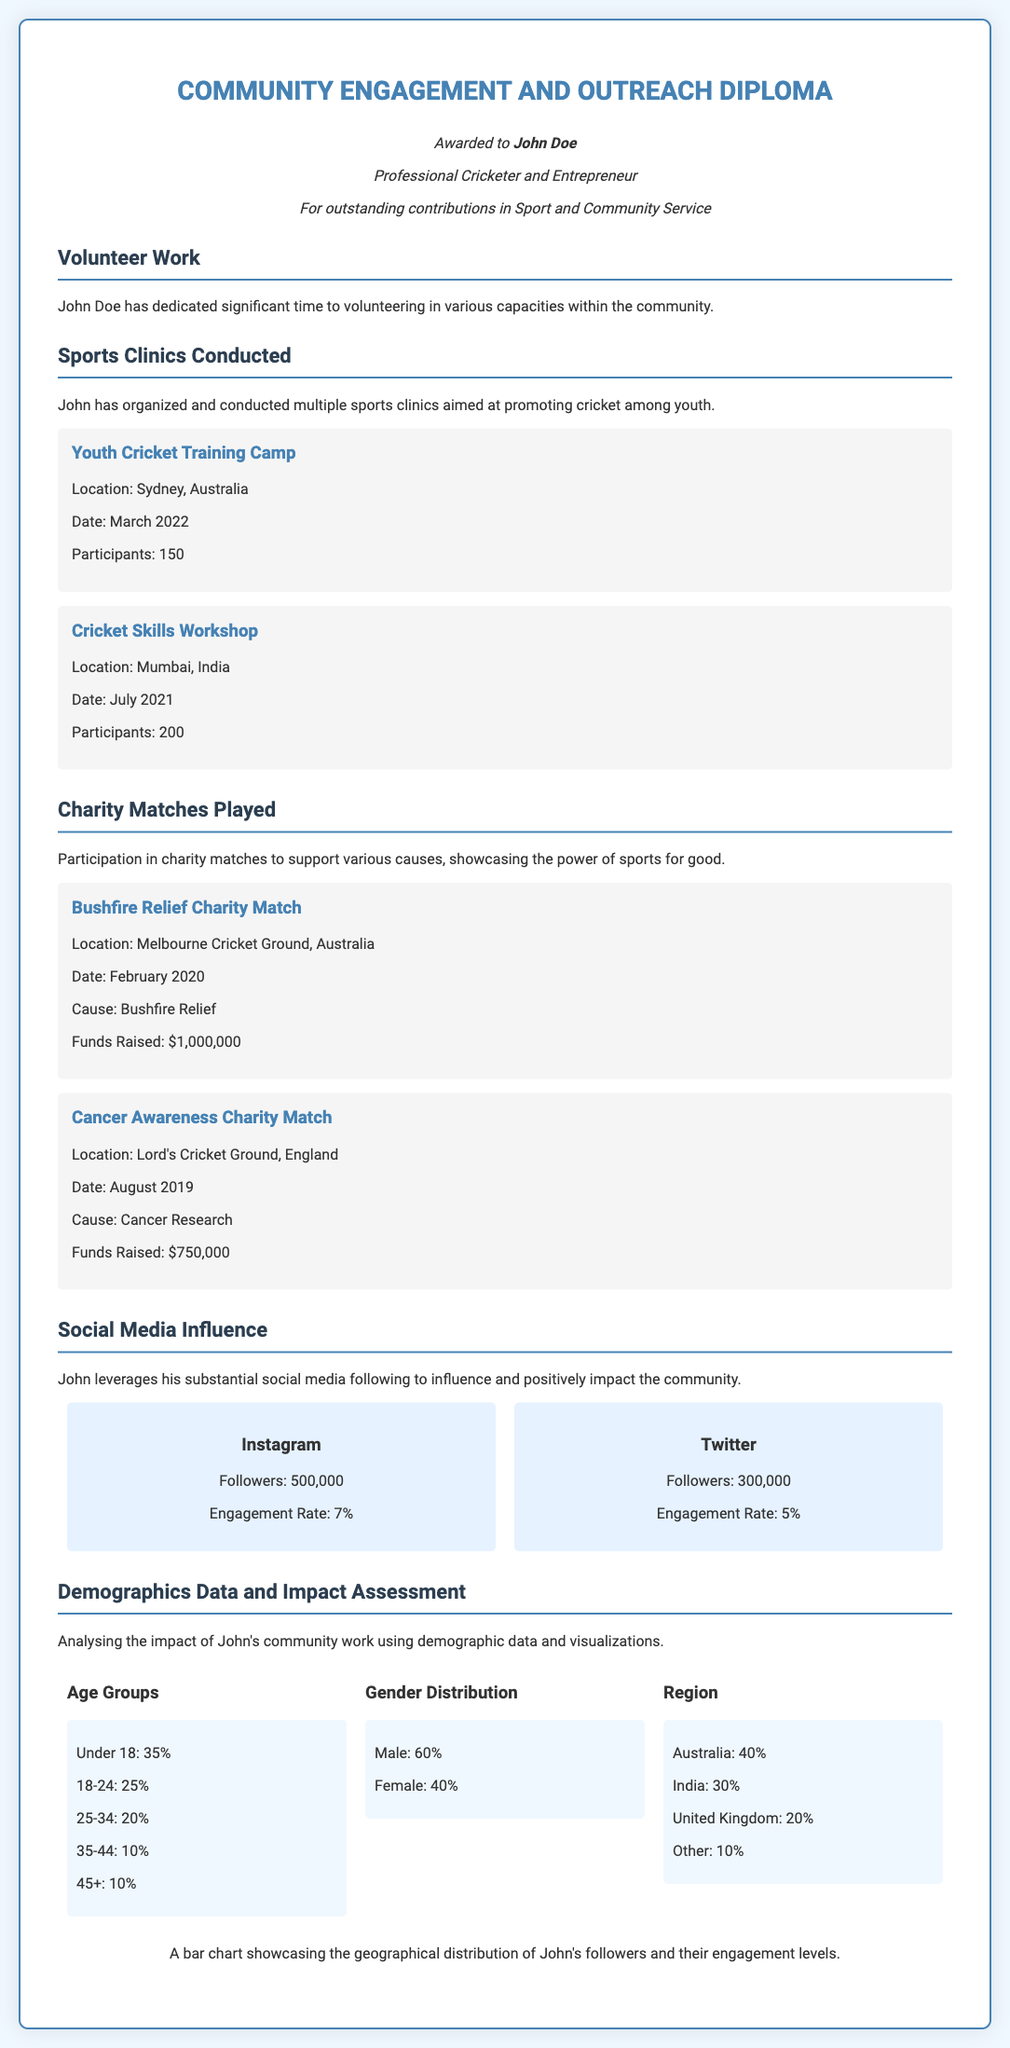What is the title of the diploma? The title is the first line in the document and indicates the focus of the achievement.
Answer: Community Engagement and Outreach Diploma Who is awarded the diploma? The diploma specifies the individual recognized for their contributions within the community.
Answer: John Doe What was the date of the Youth Cricket Training Camp? The document lists specific dates for the events, and this camp date can be found in the Sports Clinics section.
Answer: March 2022 How much money was raised in the Bushfire Relief Charity Match? The amount raised is provided for each charity match, specifically mentioned in the Charity Matches Played section.
Answer: $1,000,000 What percentage of participants at the sports clinics were under 18? The document provides demographic details regarding age group distribution among participants.
Answer: 35% How many followers does John have on Twitter? The social media section presents statistics regarding John’s social media presence.
Answer: 300,000 What cause was supported by the Cancer Awareness Charity Match? Each charity match description specifies the cause it supported.
Answer: Cancer Research What is the engagement rate on Instagram? The social media engagement rates are included in the respective section for each platform.
Answer: 7% Which country has the highest demographic percentage of John's community impact evaluations? The region data provided in the demographics section indicates the highest percentage of participants.
Answer: Australia 